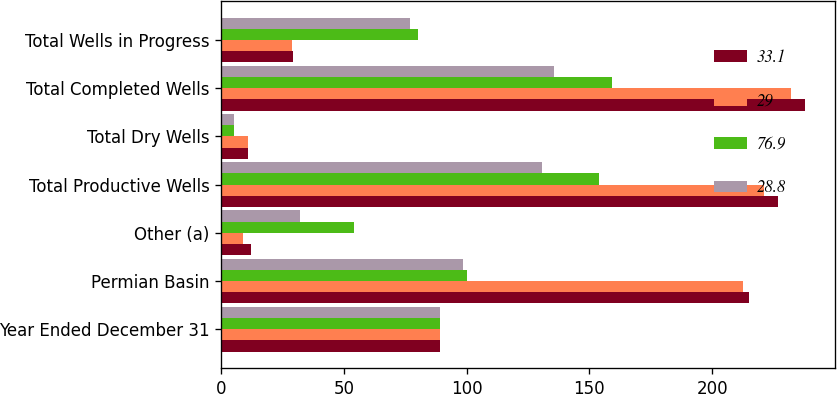<chart> <loc_0><loc_0><loc_500><loc_500><stacked_bar_chart><ecel><fcel>Year Ended December 31<fcel>Permian Basin<fcel>Other (a)<fcel>Total Productive Wells<fcel>Total Dry Wells<fcel>Total Completed Wells<fcel>Total Wells in Progress<nl><fcel>33.1<fcel>89.25<fcel>215<fcel>12<fcel>227<fcel>11<fcel>238<fcel>29<nl><fcel>29<fcel>89.25<fcel>212.5<fcel>8.8<fcel>221.3<fcel>11<fcel>232.3<fcel>28.8<nl><fcel>76.9<fcel>89.25<fcel>100<fcel>54<fcel>154<fcel>5<fcel>159<fcel>80<nl><fcel>28.8<fcel>89.25<fcel>98.5<fcel>32.2<fcel>130.7<fcel>5<fcel>135.7<fcel>76.9<nl></chart> 